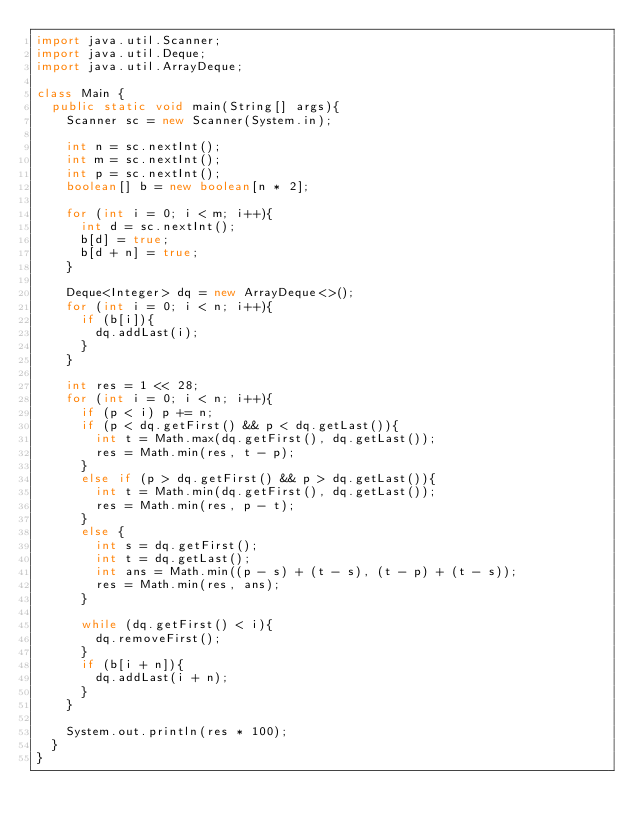<code> <loc_0><loc_0><loc_500><loc_500><_Java_>import java.util.Scanner;
import java.util.Deque;
import java.util.ArrayDeque;

class Main {
	public static void main(String[] args){
		Scanner sc = new Scanner(System.in);
		
		int n = sc.nextInt();
		int m = sc.nextInt();
		int p = sc.nextInt();
		boolean[] b = new boolean[n * 2];
		
		for (int i = 0; i < m; i++){
			int d = sc.nextInt();
			b[d] = true;
			b[d + n] = true;
		}
		
		Deque<Integer> dq = new ArrayDeque<>();
		for (int i = 0; i < n; i++){
			if (b[i]){
				dq.addLast(i);
			}
		}
		
		int res = 1 << 28;
		for (int i = 0; i < n; i++){
			if (p < i) p += n;
			if (p < dq.getFirst() && p < dq.getLast()){
				int t = Math.max(dq.getFirst(), dq.getLast());
				res = Math.min(res, t - p);
			}
			else if (p > dq.getFirst() && p > dq.getLast()){
				int t = Math.min(dq.getFirst(), dq.getLast());
				res = Math.min(res, p - t);
			}
			else {
				int s = dq.getFirst();
				int t = dq.getLast();
				int ans = Math.min((p - s) + (t - s), (t - p) + (t - s));
				res = Math.min(res, ans);
			}
			
			while (dq.getFirst() < i){
				dq.removeFirst();
			}
			if (b[i + n]){
				dq.addLast(i + n);
			}
		}
		
		System.out.println(res * 100);
	}
}</code> 